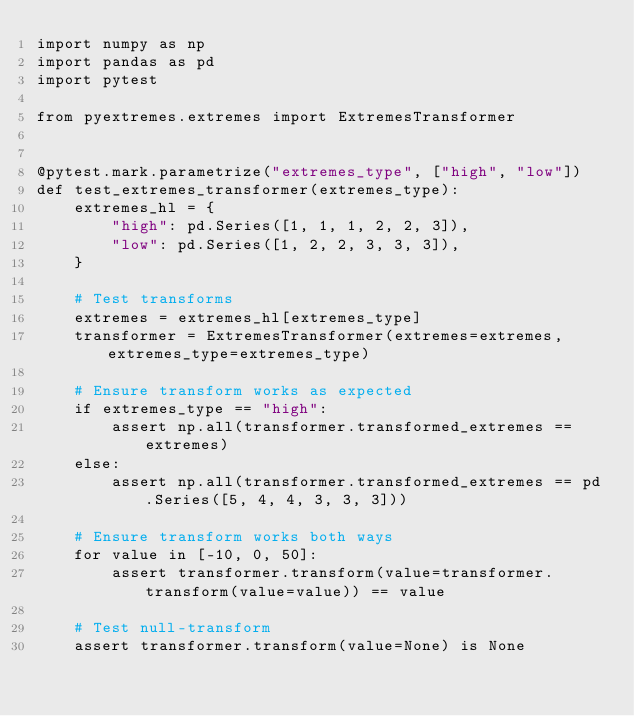<code> <loc_0><loc_0><loc_500><loc_500><_Python_>import numpy as np
import pandas as pd
import pytest

from pyextremes.extremes import ExtremesTransformer


@pytest.mark.parametrize("extremes_type", ["high", "low"])
def test_extremes_transformer(extremes_type):
    extremes_hl = {
        "high": pd.Series([1, 1, 1, 2, 2, 3]),
        "low": pd.Series([1, 2, 2, 3, 3, 3]),
    }

    # Test transforms
    extremes = extremes_hl[extremes_type]
    transformer = ExtremesTransformer(extremes=extremes, extremes_type=extremes_type)

    # Ensure transform works as expected
    if extremes_type == "high":
        assert np.all(transformer.transformed_extremes == extremes)
    else:
        assert np.all(transformer.transformed_extremes == pd.Series([5, 4, 4, 3, 3, 3]))

    # Ensure transform works both ways
    for value in [-10, 0, 50]:
        assert transformer.transform(value=transformer.transform(value=value)) == value

    # Test null-transform
    assert transformer.transform(value=None) is None
</code> 